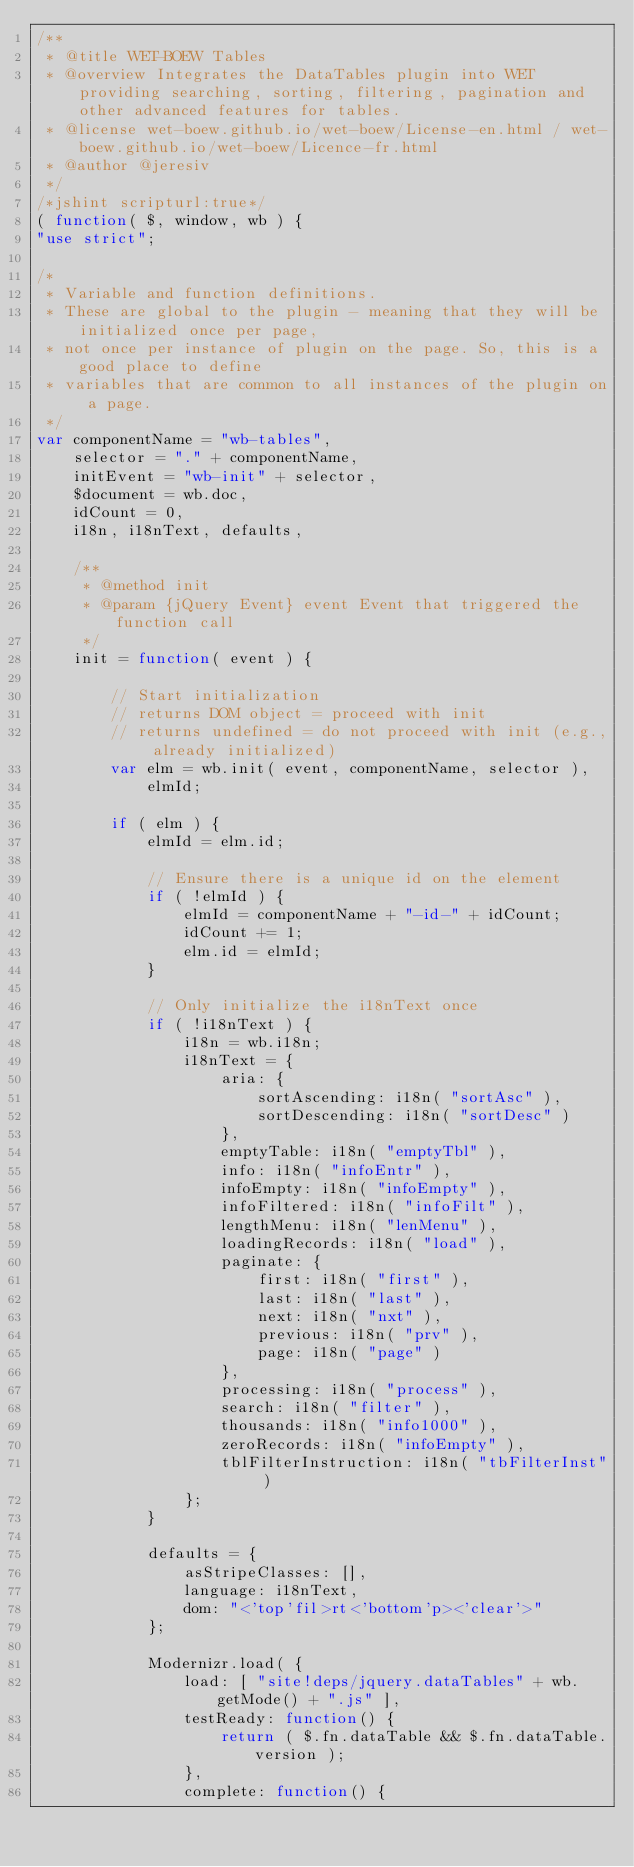<code> <loc_0><loc_0><loc_500><loc_500><_JavaScript_>/**
 * @title WET-BOEW Tables
 * @overview Integrates the DataTables plugin into WET providing searching, sorting, filtering, pagination and other advanced features for tables.
 * @license wet-boew.github.io/wet-boew/License-en.html / wet-boew.github.io/wet-boew/Licence-fr.html
 * @author @jeresiv
 */
/*jshint scripturl:true*/
( function( $, window, wb ) {
"use strict";

/*
 * Variable and function definitions.
 * These are global to the plugin - meaning that they will be initialized once per page,
 * not once per instance of plugin on the page. So, this is a good place to define
 * variables that are common to all instances of the plugin on a page.
 */
var componentName = "wb-tables",
	selector = "." + componentName,
	initEvent = "wb-init" + selector,
	$document = wb.doc,
	idCount = 0,
	i18n, i18nText, defaults,

	/**
	 * @method init
	 * @param {jQuery Event} event Event that triggered the function call
	 */
	init = function( event ) {

		// Start initialization
		// returns DOM object = proceed with init
		// returns undefined = do not proceed with init (e.g., already initialized)
		var elm = wb.init( event, componentName, selector ),
			elmId;

		if ( elm ) {
			elmId = elm.id;

			// Ensure there is a unique id on the element
			if ( !elmId ) {
				elmId = componentName + "-id-" + idCount;
				idCount += 1;
				elm.id = elmId;
			}

			// Only initialize the i18nText once
			if ( !i18nText ) {
				i18n = wb.i18n;
				i18nText = {
					aria: {
						sortAscending: i18n( "sortAsc" ),
						sortDescending: i18n( "sortDesc" )
					},
					emptyTable: i18n( "emptyTbl" ),
					info: i18n( "infoEntr" ),
					infoEmpty: i18n( "infoEmpty" ),
					infoFiltered: i18n( "infoFilt" ),
					lengthMenu: i18n( "lenMenu" ),
					loadingRecords: i18n( "load" ),
					paginate: {
						first: i18n( "first" ),
						last: i18n( "last" ),
						next: i18n( "nxt" ),
						previous: i18n( "prv" ),
						page: i18n( "page" )
					},
					processing: i18n( "process" ),
					search: i18n( "filter" ),
					thousands: i18n( "info1000" ),
					zeroRecords: i18n( "infoEmpty" ),
					tblFilterInstruction: i18n( "tbFilterInst" )
				};
			}

			defaults = {
				asStripeClasses: [],
				language: i18nText,
				dom: "<'top'fil>rt<'bottom'p><'clear'>"
			};

			Modernizr.load( {
				load: [ "site!deps/jquery.dataTables" + wb.getMode() + ".js" ],
				testReady: function() {
					return ( $.fn.dataTable && $.fn.dataTable.version );
				},
				complete: function() {</code> 